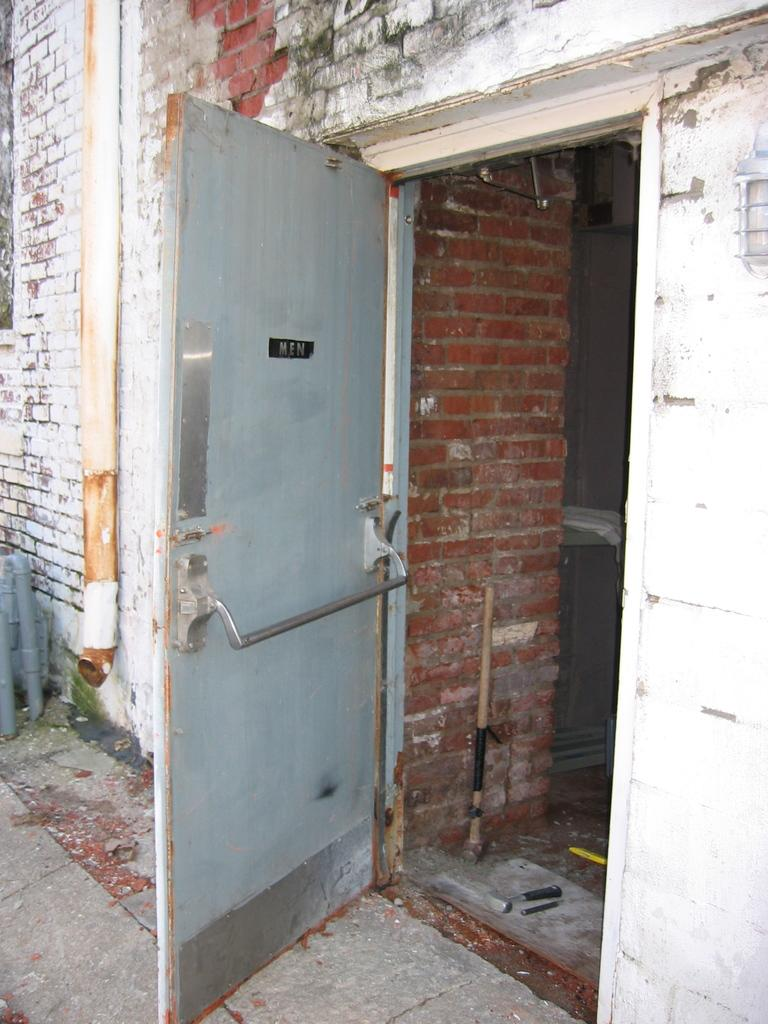What type of structure can be seen in the image? There is a door and a wall with bricks in the image. What other objects can be seen in the image? There is a pipe, a hammer, and a lamp in the image. What type of prose is being recited by the lamp in the image? There is no indication in the image that the lamp is reciting any prose, as it is an inanimate object and cannot speak or recite anything. 